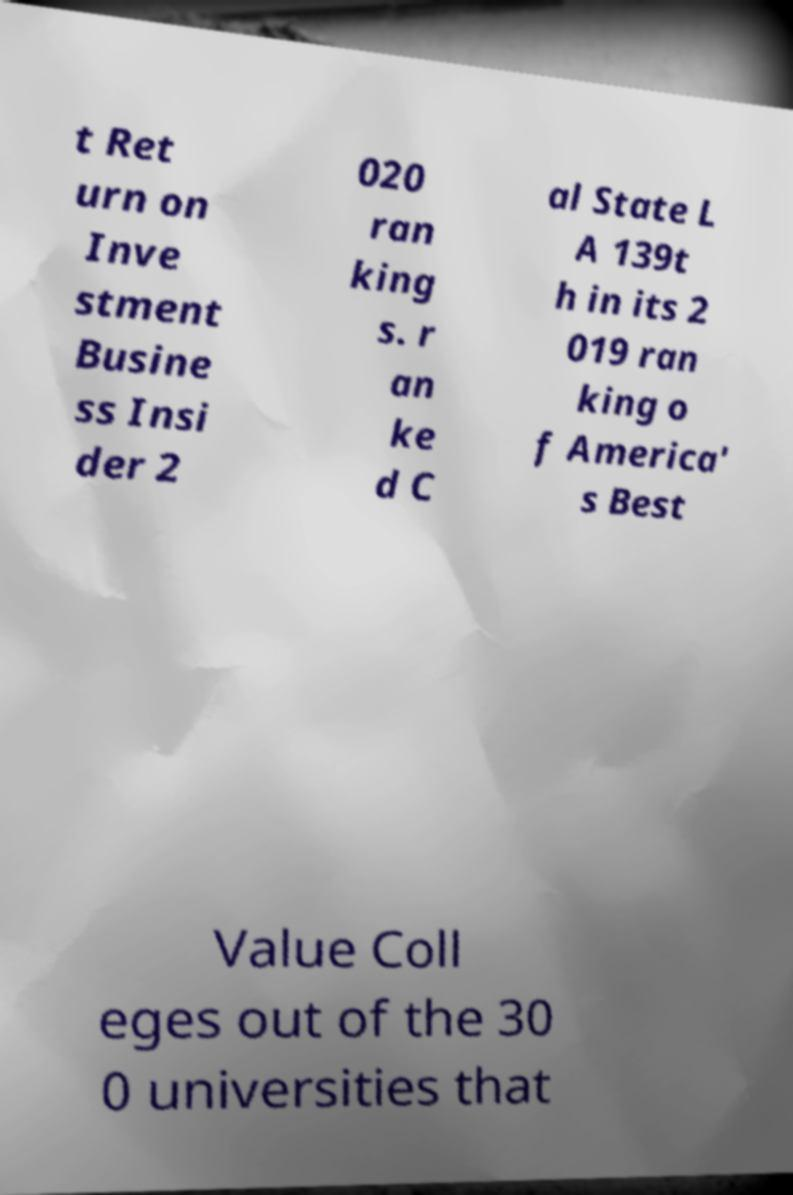What messages or text are displayed in this image? I need them in a readable, typed format. t Ret urn on Inve stment Busine ss Insi der 2 020 ran king s. r an ke d C al State L A 139t h in its 2 019 ran king o f America' s Best Value Coll eges out of the 30 0 universities that 